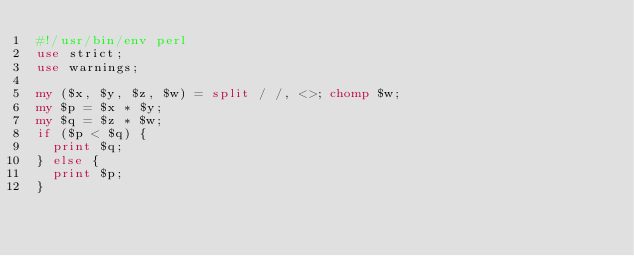Convert code to text. <code><loc_0><loc_0><loc_500><loc_500><_Perl_>#!/usr/bin/env perl
use strict;
use warnings;

my ($x, $y, $z, $w) = split / /, <>; chomp $w;
my $p = $x * $y;
my $q = $z * $w;
if ($p < $q) {
  print $q;
} else {
  print $p;
}
</code> 